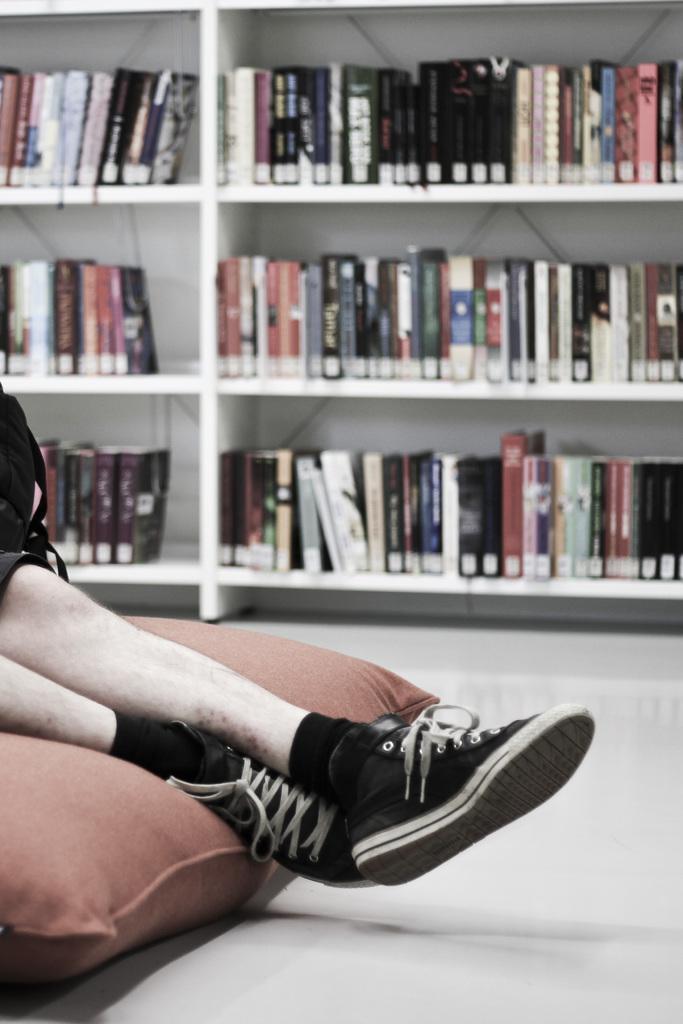Can you describe this image briefly? In the foreground of the picture there are legs of a person, on a pillow. In the background of the picture there are books, in a bookshelf. 